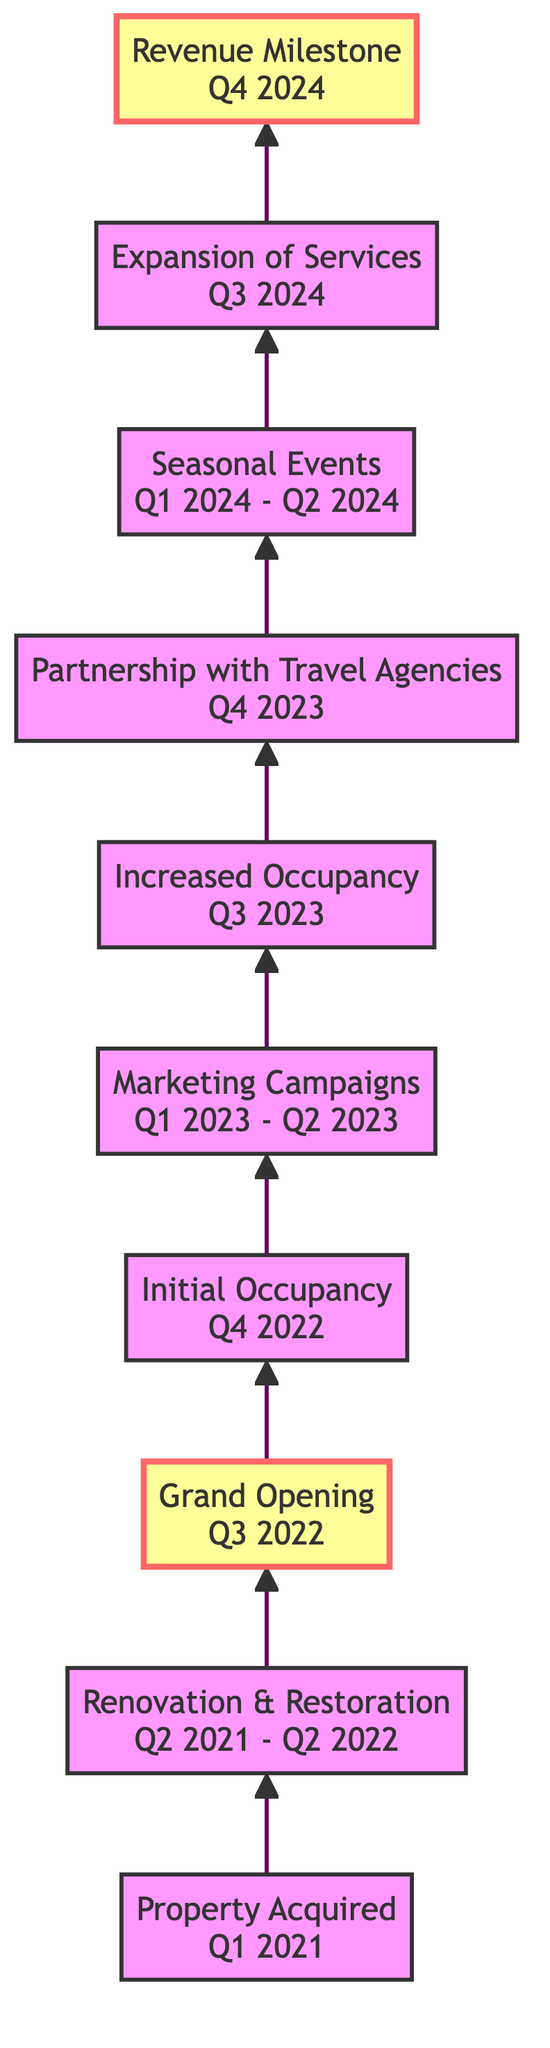What is the time period for "Renovation & Restoration"? The diagram shows that "Renovation & Restoration" occurs from Q2 2021 to Q2 2022. This is indicated directly in the node associated with this step in the flowchart.
Answer: Q2 2021 - Q2 2022 What milestone comes after the "Grand Opening"? The flowchart indicates that after "Grand Opening" in Q3 2022, the next event is "Initial Occupancy" in Q4 2022. This flow is visualized with a direct arrow leading to the next node.
Answer: Initial Occupancy How many total events are shown in the diagram? Counting each node in the flowchart, we find a total of 10 events, including both milestones and intervals. Each of the steps represents a distinct phase in the revenue growth process for the historical boutique hotel.
Answer: 10 Which event directly leads to "Increased Occupancy"? The node preceding "Increased Occupancy" is "Marketing Campaigns," which takes place from Q1 2023 to Q2 2023. The diagram depicts a direct connection through an arrow from the marketing campaigns to the increased occupancy.
Answer: Marketing Campaigns What follows "Seasonal Events"? According to the flow, "Expansion of Services" follows "Seasonal Events." The progression from one event to the next is clearly delineated in the diagram by the arrows connecting the nodes.
Answer: Expansion of Services What is the description of "Revenue Milestone"? The description provided in the diagram for "Revenue Milestone" states that it marks the achievement of significant revenue growth, doubling initial projections. This is a key point highlighted within the milestone node itself.
Answer: Achievement of significant revenue growth, doubling initial projections What did the property acquire first? The first event listed in the diagram is "Property Acquired," which represents the acquisition of the historical landmark. This is the starting point and initial step in the flow of events.
Answer: Property Acquired Which quarter signifies the "Grand Opening"? The diagram specifies that the "Grand Opening" took place in Q3 2022. This detail is clearly stated within the corresponding node connected in the flowchart.
Answer: Q3 2022 